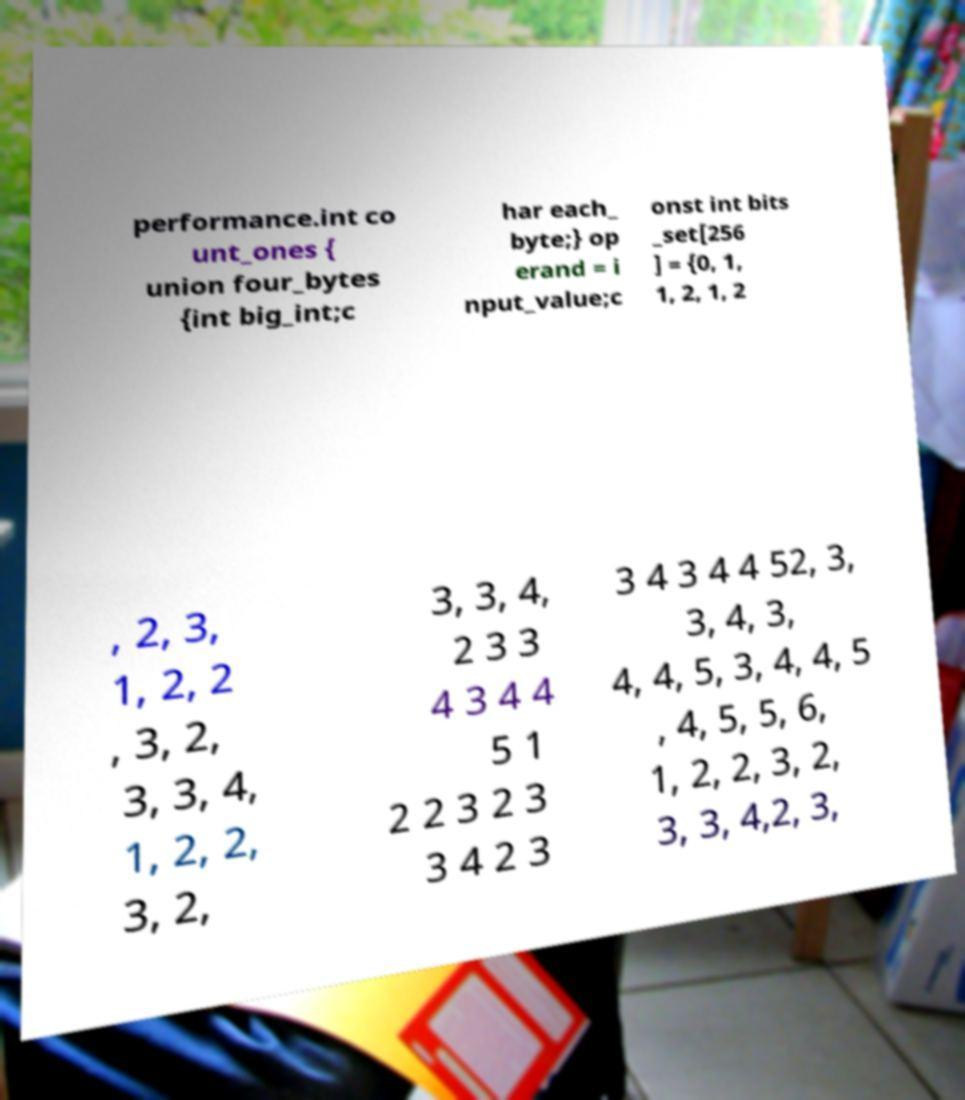Please identify and transcribe the text found in this image. performance.int co unt_ones { union four_bytes {int big_int;c har each_ byte;} op erand = i nput_value;c onst int bits _set[256 ] = {0, 1, 1, 2, 1, 2 , 2, 3, 1, 2, 2 , 3, 2, 3, 3, 4, 1, 2, 2, 3, 2, 3, 3, 4, 2 3 3 4 3 4 4 5 1 2 2 3 2 3 3 4 2 3 3 4 3 4 4 52, 3, 3, 4, 3, 4, 4, 5, 3, 4, 4, 5 , 4, 5, 5, 6, 1, 2, 2, 3, 2, 3, 3, 4,2, 3, 